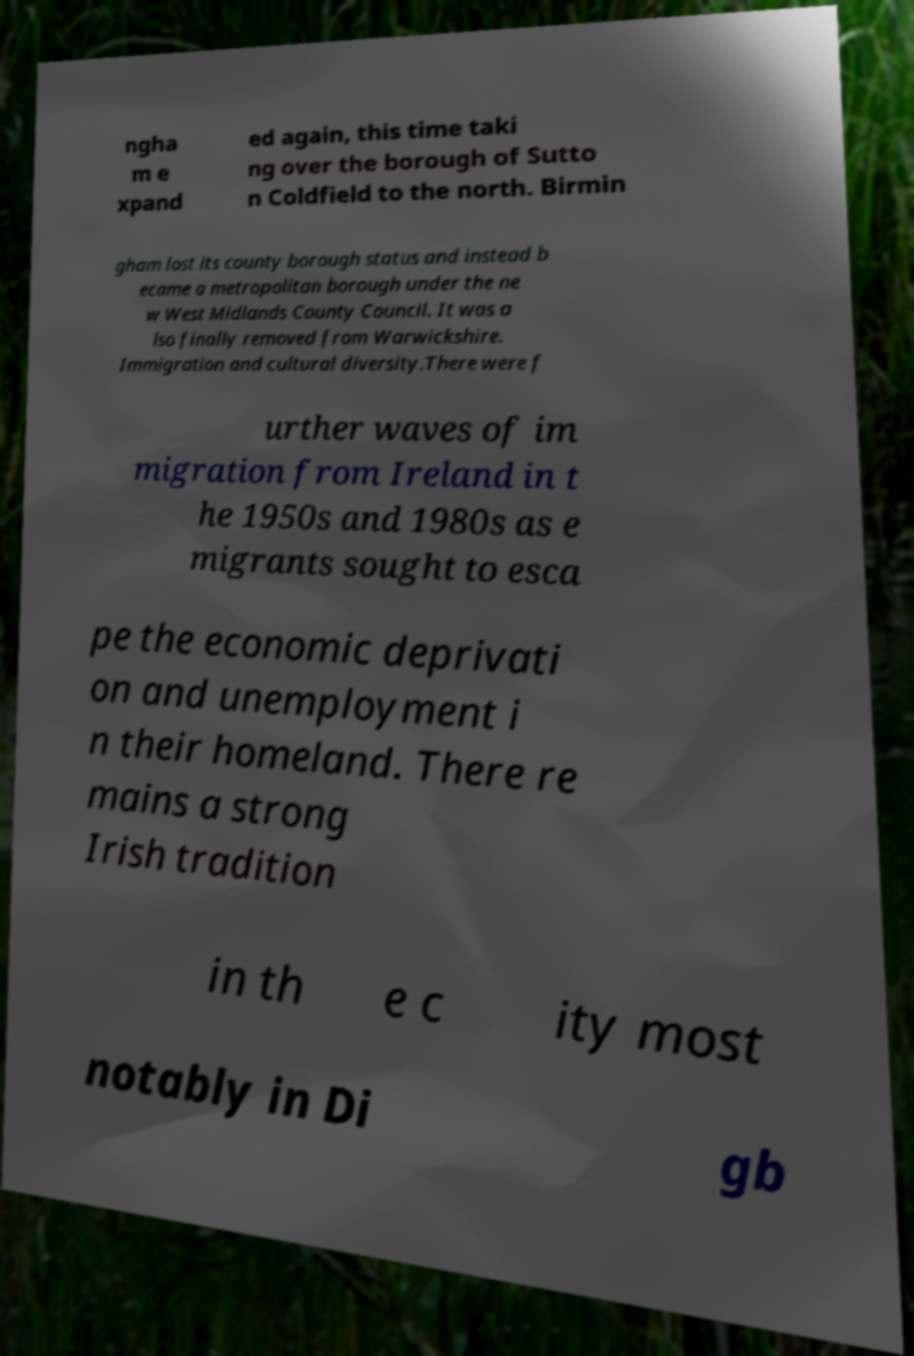Could you extract and type out the text from this image? ngha m e xpand ed again, this time taki ng over the borough of Sutto n Coldfield to the north. Birmin gham lost its county borough status and instead b ecame a metropolitan borough under the ne w West Midlands County Council. It was a lso finally removed from Warwickshire. Immigration and cultural diversity.There were f urther waves of im migration from Ireland in t he 1950s and 1980s as e migrants sought to esca pe the economic deprivati on and unemployment i n their homeland. There re mains a strong Irish tradition in th e c ity most notably in Di gb 